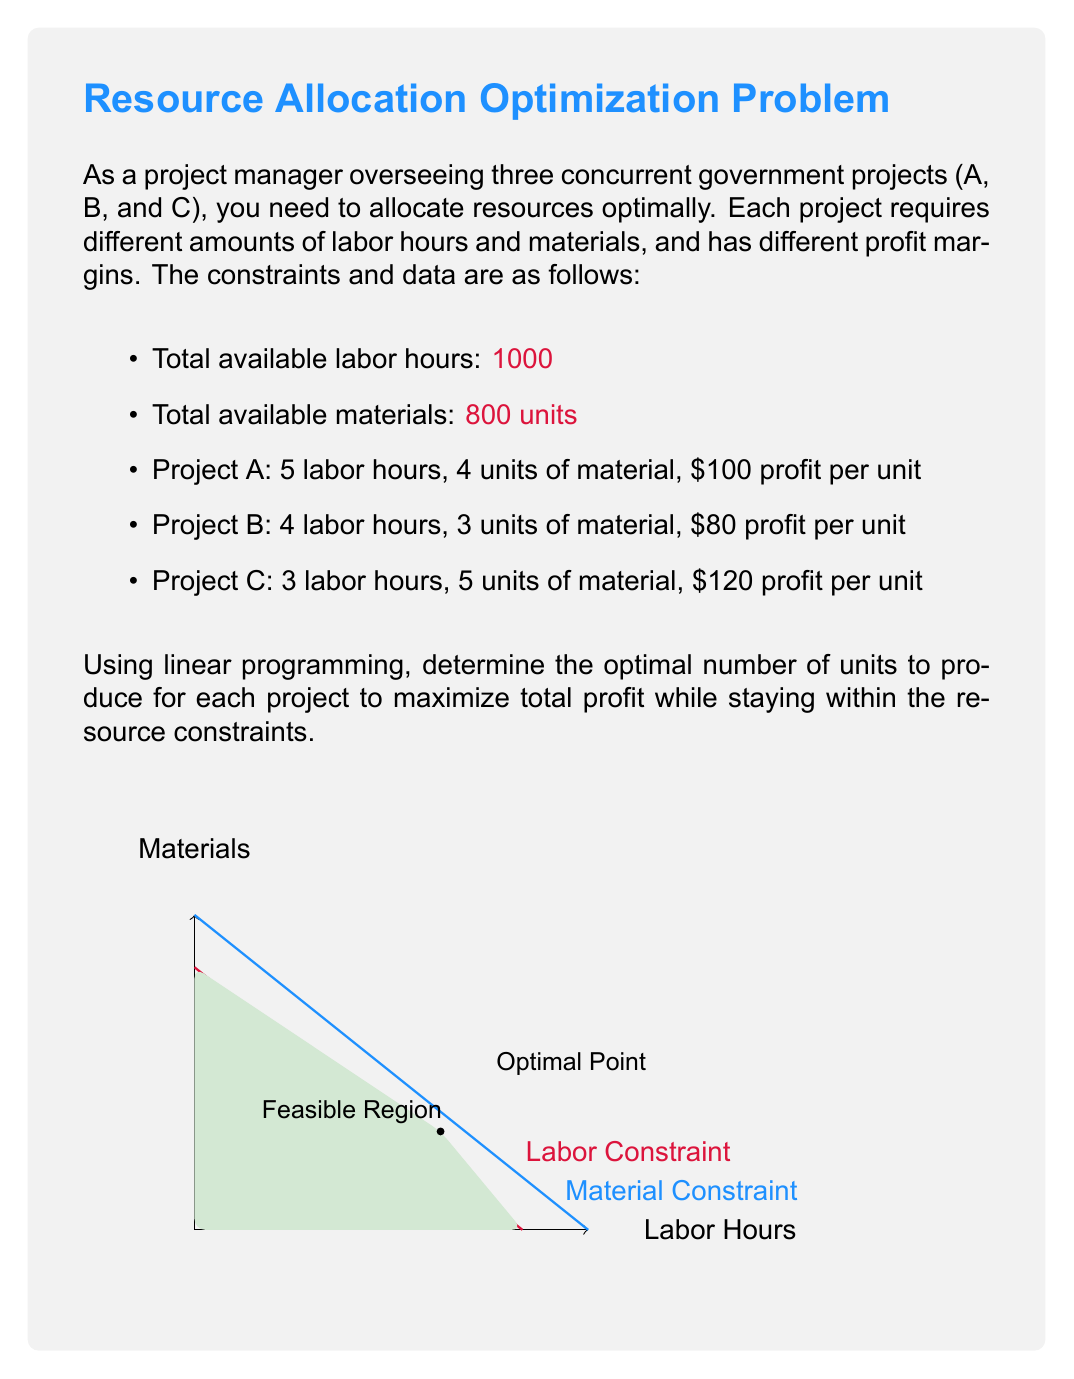Can you solve this math problem? To solve this linear programming problem, we'll follow these steps:

1) Define variables:
   Let $x$, $y$, and $z$ be the number of units produced for projects A, B, and C respectively.

2) Set up the objective function:
   Maximize $P = 100x + 80y + 120z$

3) Define constraints:
   Labor: $5x + 4y + 3z \leq 1000$
   Materials: $4x + 3y + 5z \leq 800$
   Non-negativity: $x, y, z \geq 0$

4) Solve using the simplex method or graphical method. For this explanation, we'll use the graphical method as we can eliminate one variable.

5) Eliminate $z$ using the material constraint:
   $5z = 800 - 4x - 3y$
   $z = 160 - 0.8x - 0.6y$

6) Substitute this into the labor constraint:
   $5x + 4y + 3(160 - 0.8x - 0.6y) \leq 1000$
   $5x + 4y + 480 - 2.4x - 1.8y \leq 1000$
   $2.6x + 2.2y \leq 520$

7) Now we have two inequalities in $x$ and $y$:
   $4x + 3y \leq 800$ (materials)
   $2.6x + 2.2y \leq 520$ (labor)

8) Plot these lines and identify the feasible region.

9) The optimal solution will be at one of the corner points of the feasible region. Calculate the coordinates of these points and evaluate the objective function at each.

10) The corner points are:
    (0, 0), (200, 0), (0, 236.36), and (125, 100)

11) Evaluating the objective function at each point:
    (0, 0): $P = 0$
    (200, 0): $P = 20,000 + 19,200 = 39,200$
    (0, 236.36): $P = 18,909 + 17,018 = 35,927$
    (125, 100): $P = 12,500 + 8,000 + 24,000 = 44,500$

Therefore, the optimal solution is to produce 125 units of project A, 100 units of project B, and 200 units of project C.
Answer: A: 125 units, B: 100 units, C: 200 units 